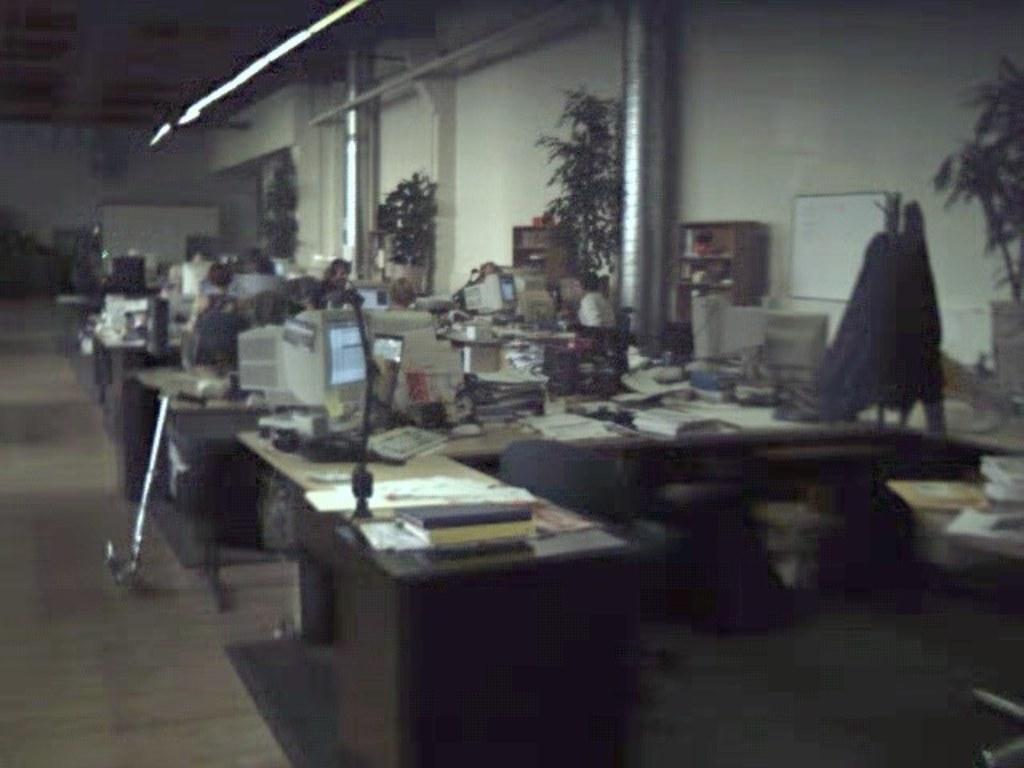How would you summarize this image in a sentence or two? In the picture we can see an office with some desks on it, we can see some computer systems, some files and some things are placed on it and some people are sitting near it and doing their work and besides, we can see some pillars and plants and in the background we can see a wall and near it we can see a white color board. 